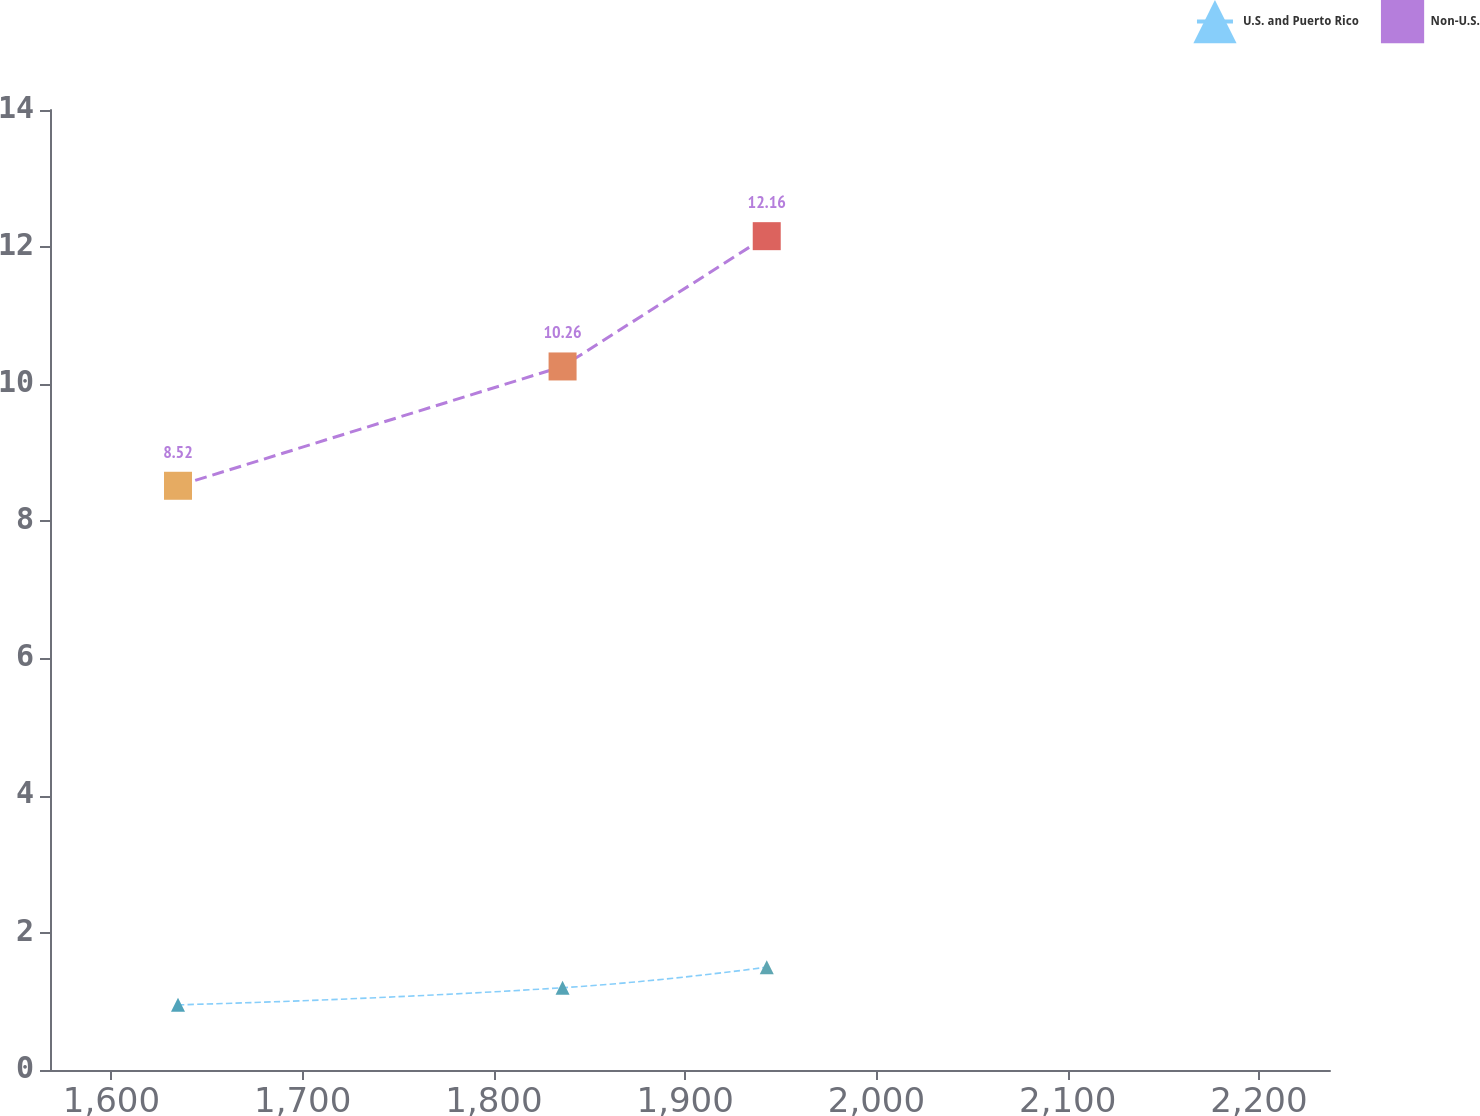<chart> <loc_0><loc_0><loc_500><loc_500><line_chart><ecel><fcel>U.S. and Puerto Rico<fcel>Non-U.S.<nl><fcel>1634.81<fcel>0.95<fcel>8.52<nl><fcel>1835.9<fcel>1.2<fcel>10.26<nl><fcel>1942.65<fcel>1.5<fcel>12.16<nl><fcel>2237.78<fcel>1.76<fcel>13.21<nl><fcel>2304.1<fcel>3.41<fcel>12.78<nl></chart> 